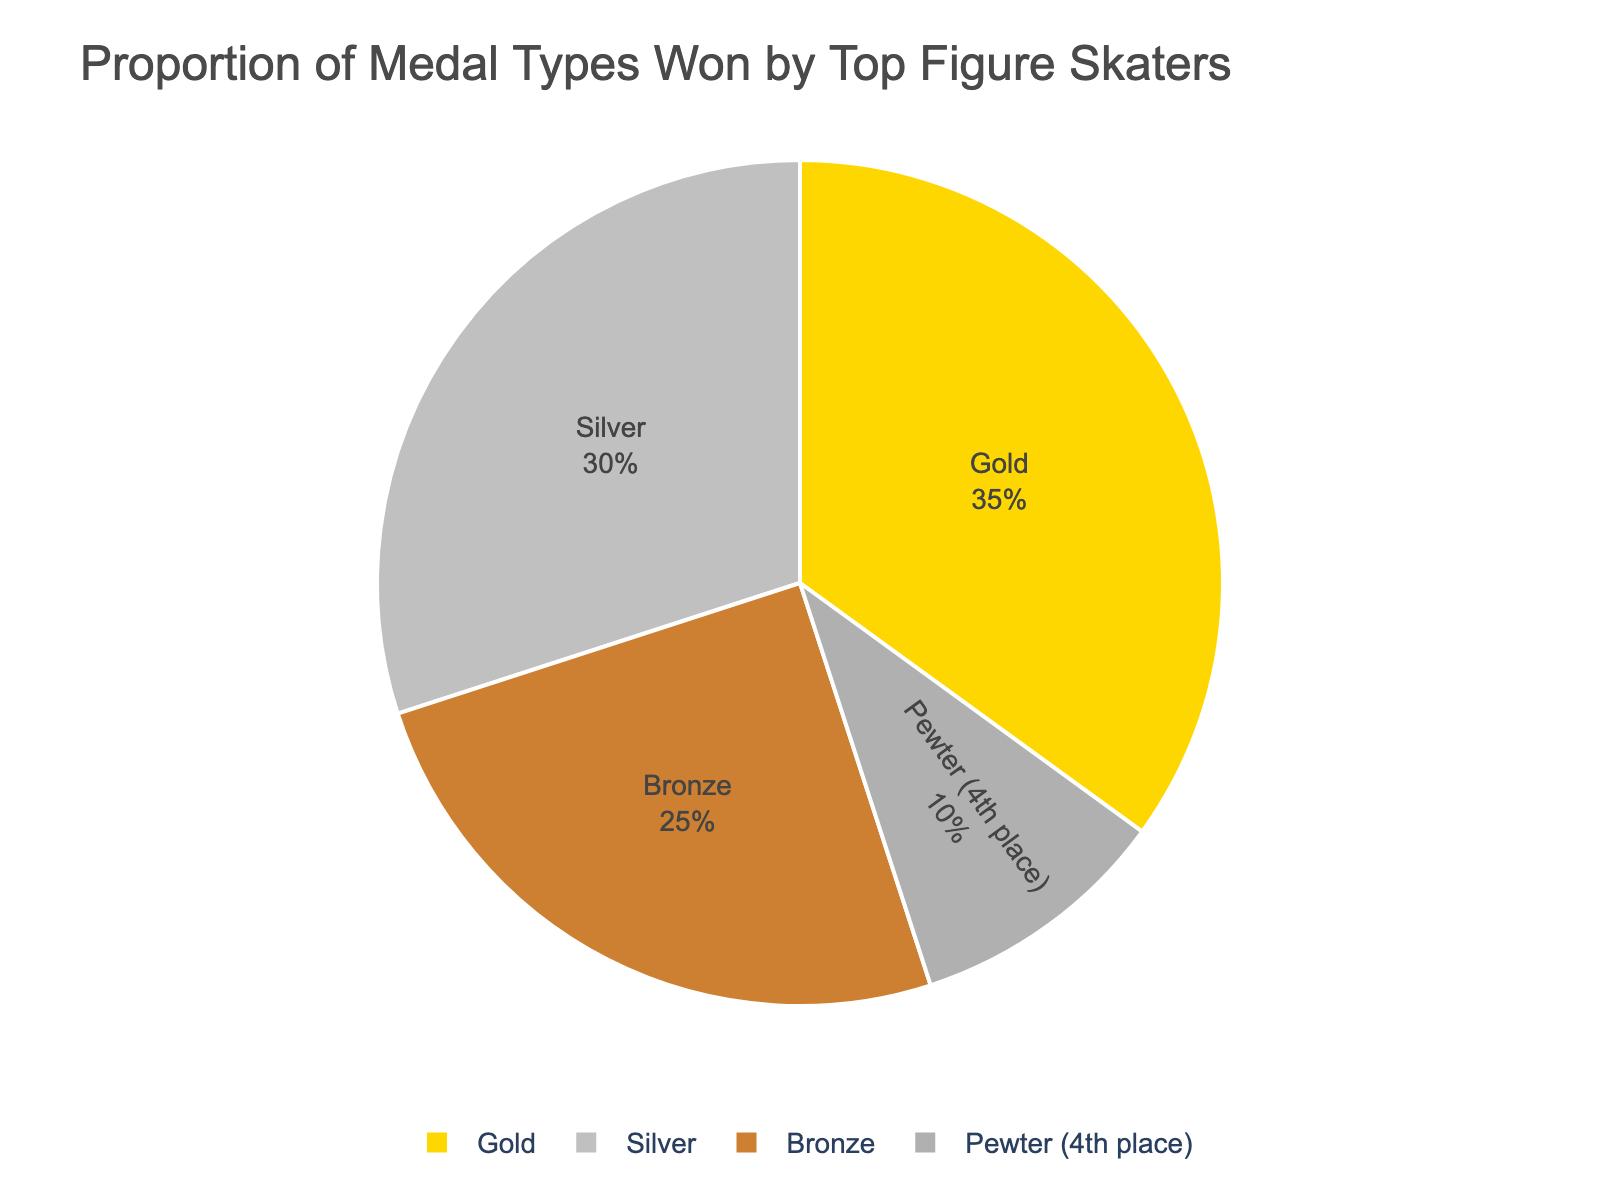What percentage of medals are either Gold or Silver? To find this, add the percentages of Gold and Silver medals. Gold is 35% and Silver is 30%. 35% + 30% = 65%
Answer: 65% Which medal type is least won by the top figure skaters? From the pie chart, Pewter (4th place) is the least won medal type at 10%.
Answer: Pewter (4th place) How much greater is the percentage of Gold medals compared to Bronze medals? The percentage of Gold medals is 35% and that of Bronze medals is 25%. Subtract the percentage of Bronze from Gold: 35% - 25% = 10%
Answer: 10% What is the combined percentage of Silver and Bronze medals? Add the percentages of Silver and Bronze medals. Silver is 30% and Bronze is 25%. 30% + 25% = 55%
Answer: 55% Compare the percentages of Silver and Pewter (4th place) medals. Which one is higher and by how much? Pewter is 10% and Silver is 30%. Silver is higher. Subtract Pewter from Silver: 30% - 10% = 20%
Answer: Silver, by 20% Which medal type occupies the largest portion of the pie chart? The largest part of the pie chart is covered by Gold medals, which is 35%.
Answer: Gold If the percentage of Silver medals increased by 5%, what would their new percentage be? The current percentage of Silver medals is 30%. Adding 5% to this: 30% + 5% = 35%
Answer: 35% How does the proportion of Bronze medals compare to the proportion of Pewter medals? From the chart, Bronze medals make up 25%, and Pewter medals make up 10%. Bronze medals have a higher proportion.
Answer: Bronze is greater What percentage composition would you get if you combined Gold and Pewter medals? Add the percentages of Gold and Pewter medals. Gold is 35% and Pewter is 10%. 35% + 10% = 45%
Answer: 45% Does any single medal type make up more than one-third of the total medals? One-third of 100% is approximately 33.33%. Gold medals make up 35%, which is more than one-third.
Answer: Yes, Gold 